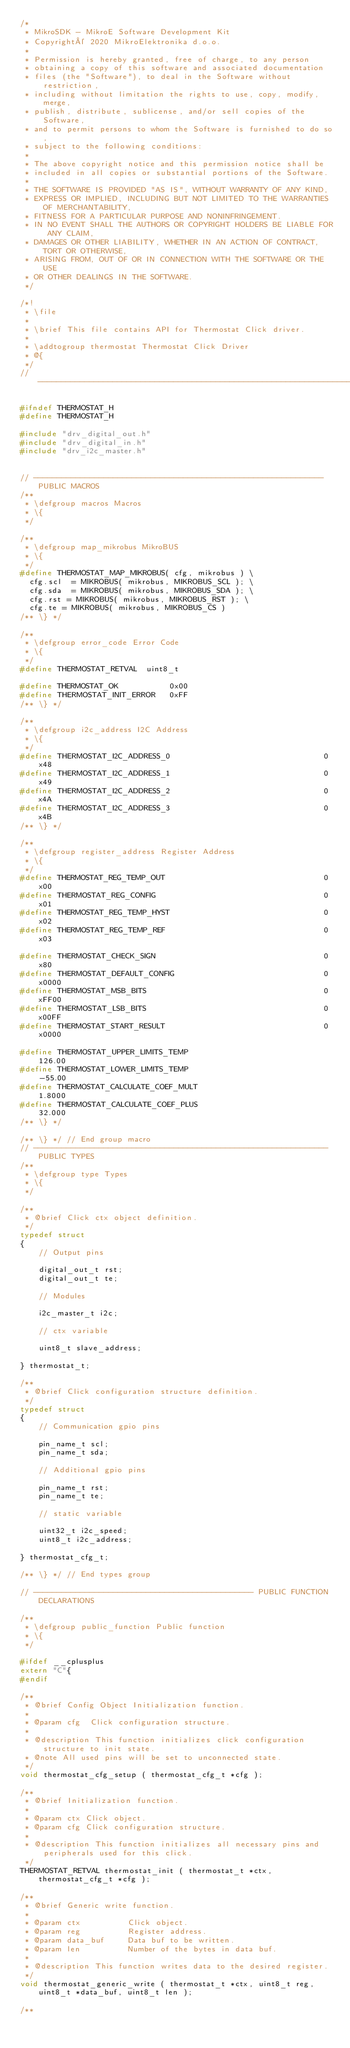Convert code to text. <code><loc_0><loc_0><loc_500><loc_500><_C_>/*
 * MikroSDK - MikroE Software Development Kit
 * Copyright© 2020 MikroElektronika d.o.o.
 * 
 * Permission is hereby granted, free of charge, to any person 
 * obtaining a copy of this software and associated documentation 
 * files (the "Software"), to deal in the Software without restriction, 
 * including without limitation the rights to use, copy, modify, merge, 
 * publish, distribute, sublicense, and/or sell copies of the Software, 
 * and to permit persons to whom the Software is furnished to do so, 
 * subject to the following conditions:
 * 
 * The above copyright notice and this permission notice shall be 
 * included in all copies or substantial portions of the Software.
 * 
 * THE SOFTWARE IS PROVIDED "AS IS", WITHOUT WARRANTY OF ANY KIND, 
 * EXPRESS OR IMPLIED, INCLUDING BUT NOT LIMITED TO THE WARRANTIES OF MERCHANTABILITY, 
 * FITNESS FOR A PARTICULAR PURPOSE AND NONINFRINGEMENT. 
 * IN NO EVENT SHALL THE AUTHORS OR COPYRIGHT HOLDERS BE LIABLE FOR ANY CLAIM,
 * DAMAGES OR OTHER LIABILITY, WHETHER IN AN ACTION OF CONTRACT, TORT OR OTHERWISE, 
 * ARISING FROM, OUT OF OR IN CONNECTION WITH THE SOFTWARE OR THE USE 
 * OR OTHER DEALINGS IN THE SOFTWARE. 
 */

/*!
 * \file
 *
 * \brief This file contains API for Thermostat Click driver.
 *
 * \addtogroup thermostat Thermostat Click Driver
 * @{
 */
// ----------------------------------------------------------------------------

#ifndef THERMOSTAT_H
#define THERMOSTAT_H

#include "drv_digital_out.h"
#include "drv_digital_in.h"
#include "drv_i2c_master.h"


// -------------------------------------------------------------- PUBLIC MACROS 
/**
 * \defgroup macros Macros
 * \{
 */

/**
 * \defgroup map_mikrobus MikroBUS
 * \{
 */
#define THERMOSTAT_MAP_MIKROBUS( cfg, mikrobus ) \
  cfg.scl  = MIKROBUS( mikrobus, MIKROBUS_SCL ); \
  cfg.sda  = MIKROBUS( mikrobus, MIKROBUS_SDA ); \
  cfg.rst = MIKROBUS( mikrobus, MIKROBUS_RST ); \
  cfg.te = MIKROBUS( mikrobus, MIKROBUS_CS )
/** \} */

/**
 * \defgroup error_code Error Code
 * \{
 */
#define THERMOSTAT_RETVAL  uint8_t

#define THERMOSTAT_OK           0x00
#define THERMOSTAT_INIT_ERROR   0xFF
/** \} */

/**
 * \defgroup i2c_address I2C Address
 * \{
 */
#define THERMOSTAT_I2C_ADDRESS_0                                 0x48
#define THERMOSTAT_I2C_ADDRESS_1                                 0x49
#define THERMOSTAT_I2C_ADDRESS_2                                 0x4A
#define THERMOSTAT_I2C_ADDRESS_3                                 0x4B
/** \} */

/**
 * \defgroup register_address Register Address
 * \{
 */
#define THERMOSTAT_REG_TEMP_OUT                                  0x00
#define THERMOSTAT_REG_CONFIG                                    0x01
#define THERMOSTAT_REG_TEMP_HYST                                 0x02
#define THERMOSTAT_REG_TEMP_REF                                  0x03

#define THERMOSTAT_CHECK_SIGN                                    0x80
#define THERMOSTAT_DEFAULT_CONFIG                                0x0000
#define THERMOSTAT_MSB_BITS                                      0xFF00
#define THERMOSTAT_LSB_BITS                                      0x00FF
#define THERMOSTAT_START_RESULT                                  0x0000

#define THERMOSTAT_UPPER_LIMITS_TEMP                             126.00
#define THERMOSTAT_LOWER_LIMITS_TEMP                             -55.00
#define THERMOSTAT_CALCULATE_COEF_MULT                           1.8000
#define THERMOSTAT_CALCULATE_COEF_PLUS                           32.000
/** \} */

/** \} */ // End group macro 
// --------------------------------------------------------------- PUBLIC TYPES
/**
 * \defgroup type Types
 * \{
 */

/**
 * @brief Click ctx object definition.
 */
typedef struct
{
    // Output pins 
 
    digital_out_t rst;
    digital_out_t te;
  
    // Modules 

    i2c_master_t i2c;

    // ctx variable 

    uint8_t slave_address;

} thermostat_t;

/**
 * @brief Click configuration structure definition.
 */
typedef struct
{
    // Communication gpio pins 

    pin_name_t scl;
    pin_name_t sda;
    
    // Additional gpio pins 

    pin_name_t rst;
    pin_name_t te;
  
    // static variable 

    uint32_t i2c_speed;
    uint8_t i2c_address;

} thermostat_cfg_t;

/** \} */ // End types group

// ----------------------------------------------- PUBLIC FUNCTION DECLARATIONS

/**
 * \defgroup public_function Public function
 * \{
 */
 
#ifdef __cplusplus
extern "C"{
#endif

/**
 * @brief Config Object Initialization function.
 *
 * @param cfg  Click configuration structure.
 *
 * @description This function initializes click configuration structure to init state.
 * @note All used pins will be set to unconnected state.
 */
void thermostat_cfg_setup ( thermostat_cfg_t *cfg );

/**
 * @brief Initialization function.
 *
 * @param ctx Click object.
 * @param cfg Click configuration structure.
 * 
 * @description This function initializes all necessary pins and peripherals used for this click.
 */
THERMOSTAT_RETVAL thermostat_init ( thermostat_t *ctx, thermostat_cfg_t *cfg );

/**
 * @brief Generic write function.
 *
 * @param ctx          Click object.
 * @param reg          Register address.
 * @param data_buf     Data buf to be written.
 * @param len          Number of the bytes in data buf.
 *
 * @description This function writes data to the desired register.
 */
void thermostat_generic_write ( thermostat_t *ctx, uint8_t reg, uint8_t *data_buf, uint8_t len );

/**</code> 